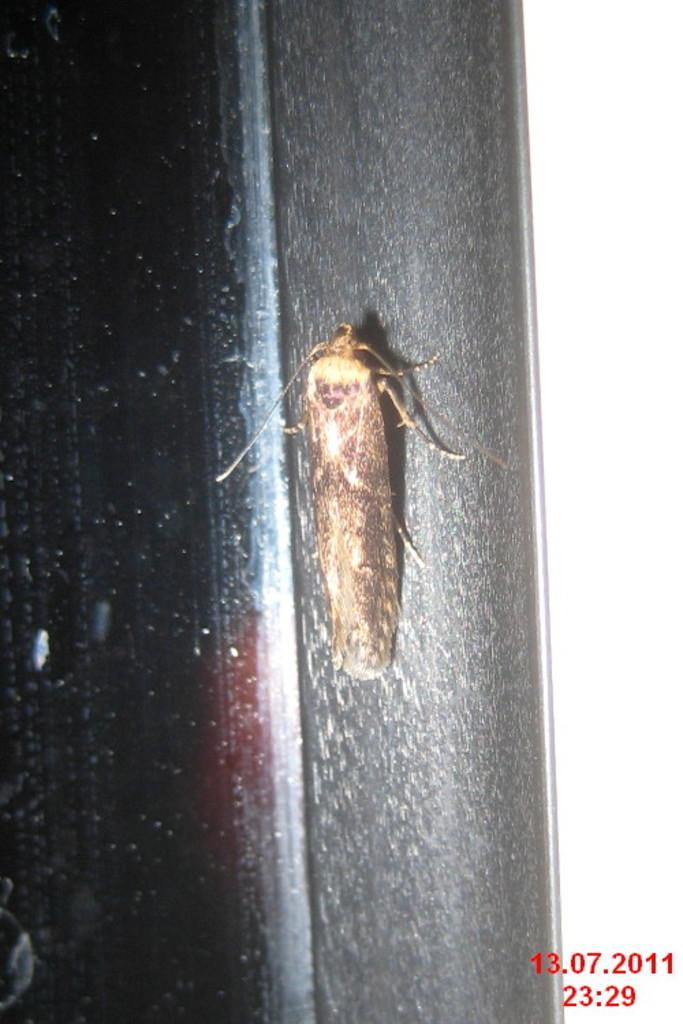Could you give a brief overview of what you see in this image? In this picture, we see a cockroach on the black pole. Beside that, we see a glass window and it is dark on the left side. On the right side of the picture, it is white in color. 